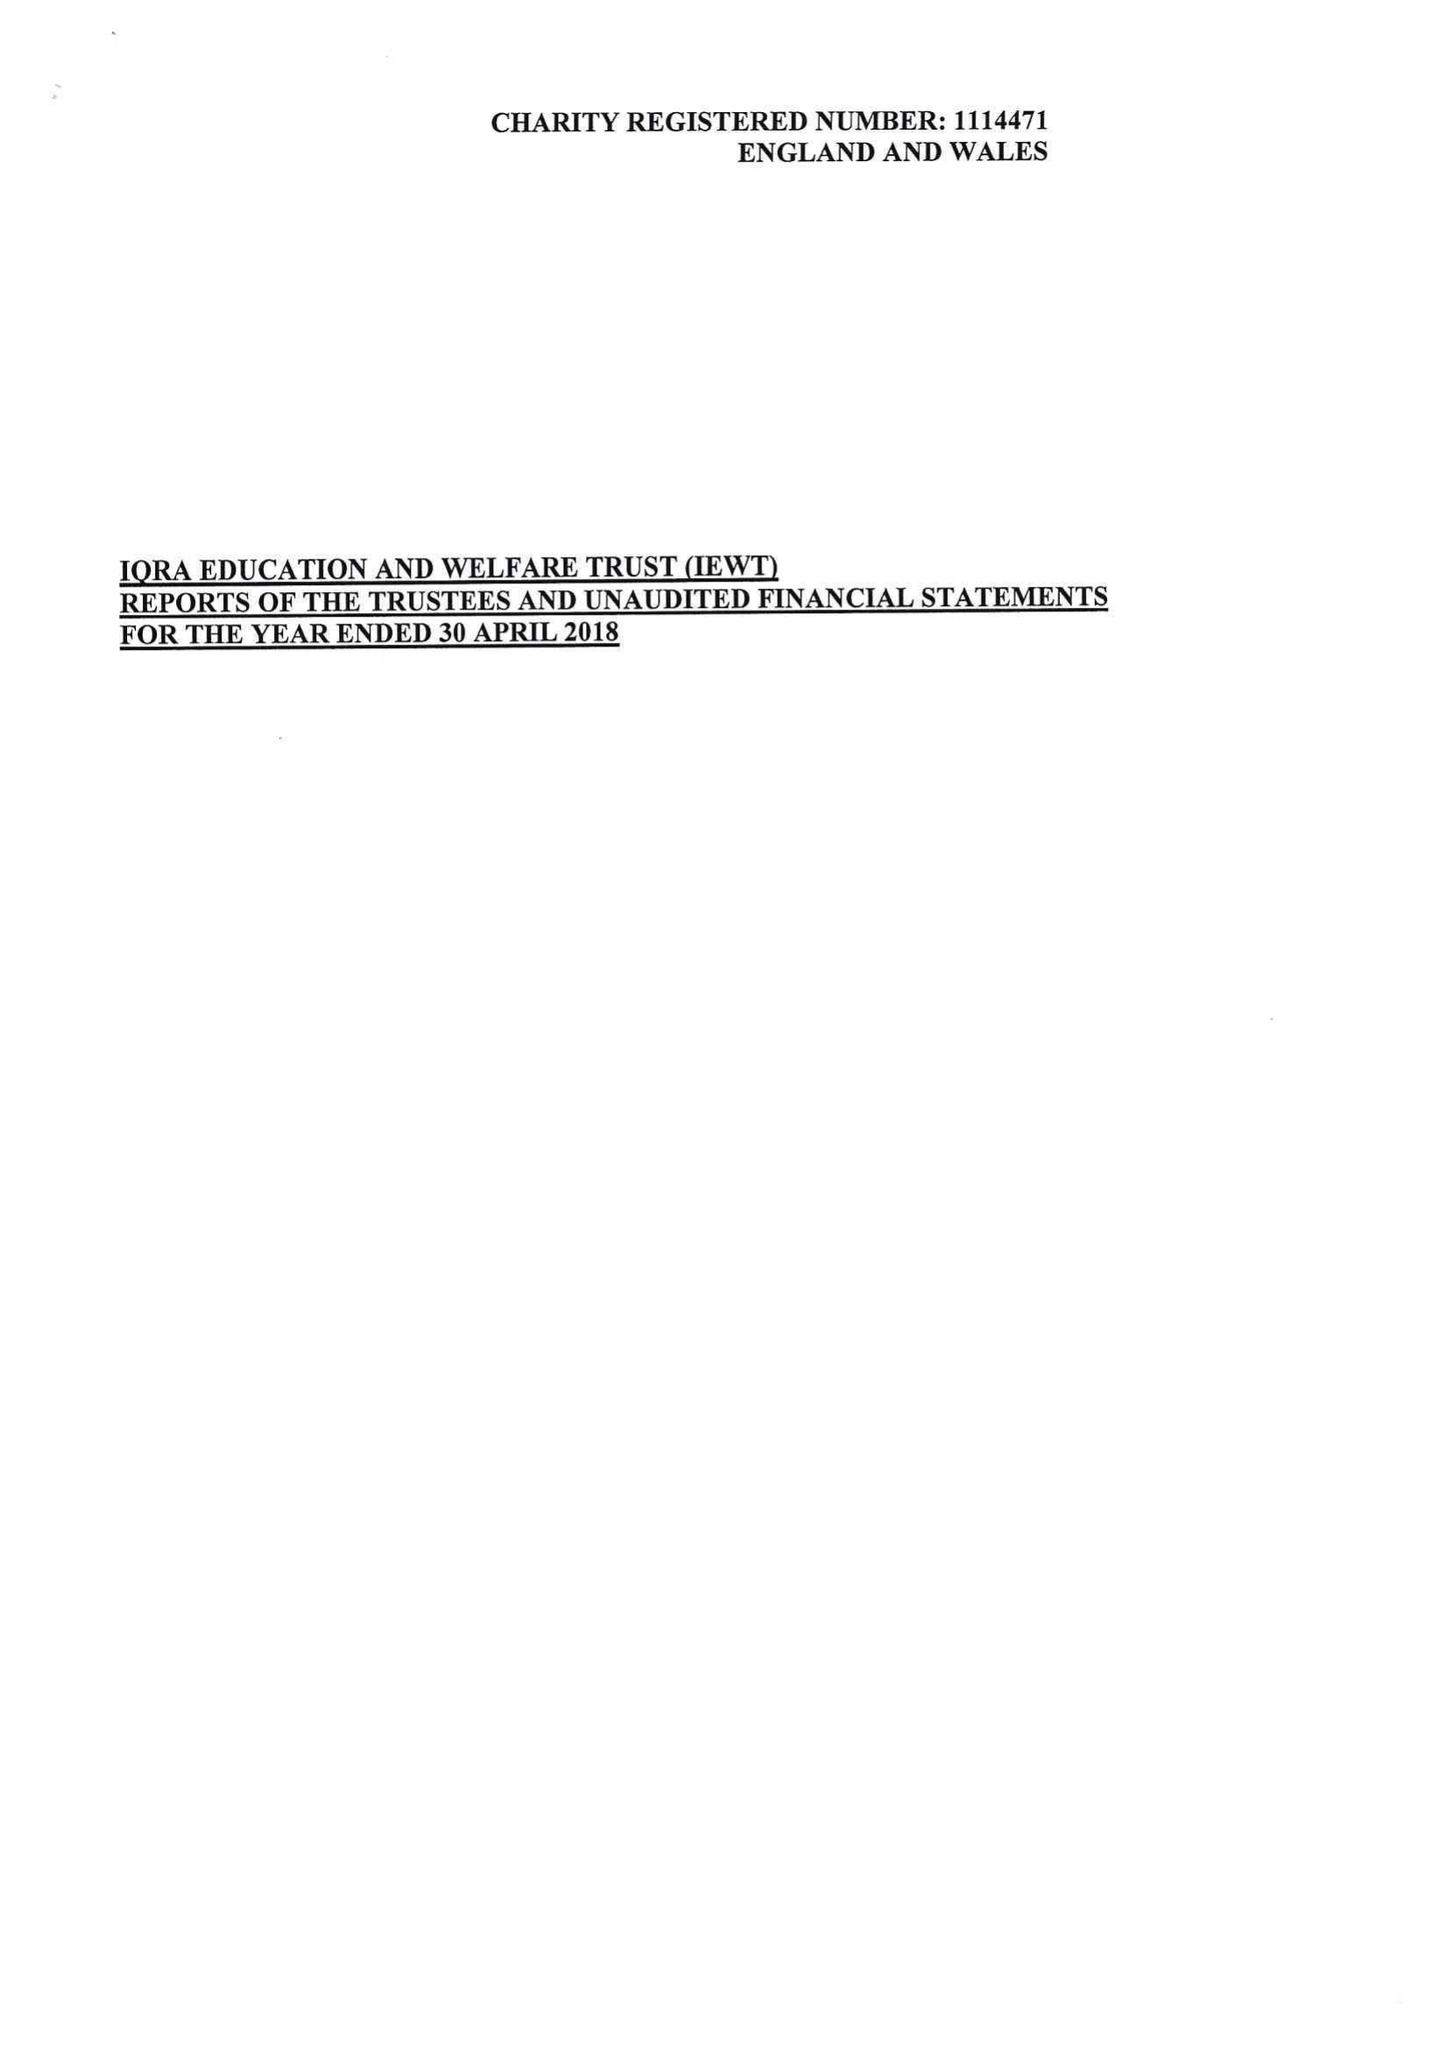What is the value for the spending_annually_in_british_pounds?
Answer the question using a single word or phrase. 132515.00 